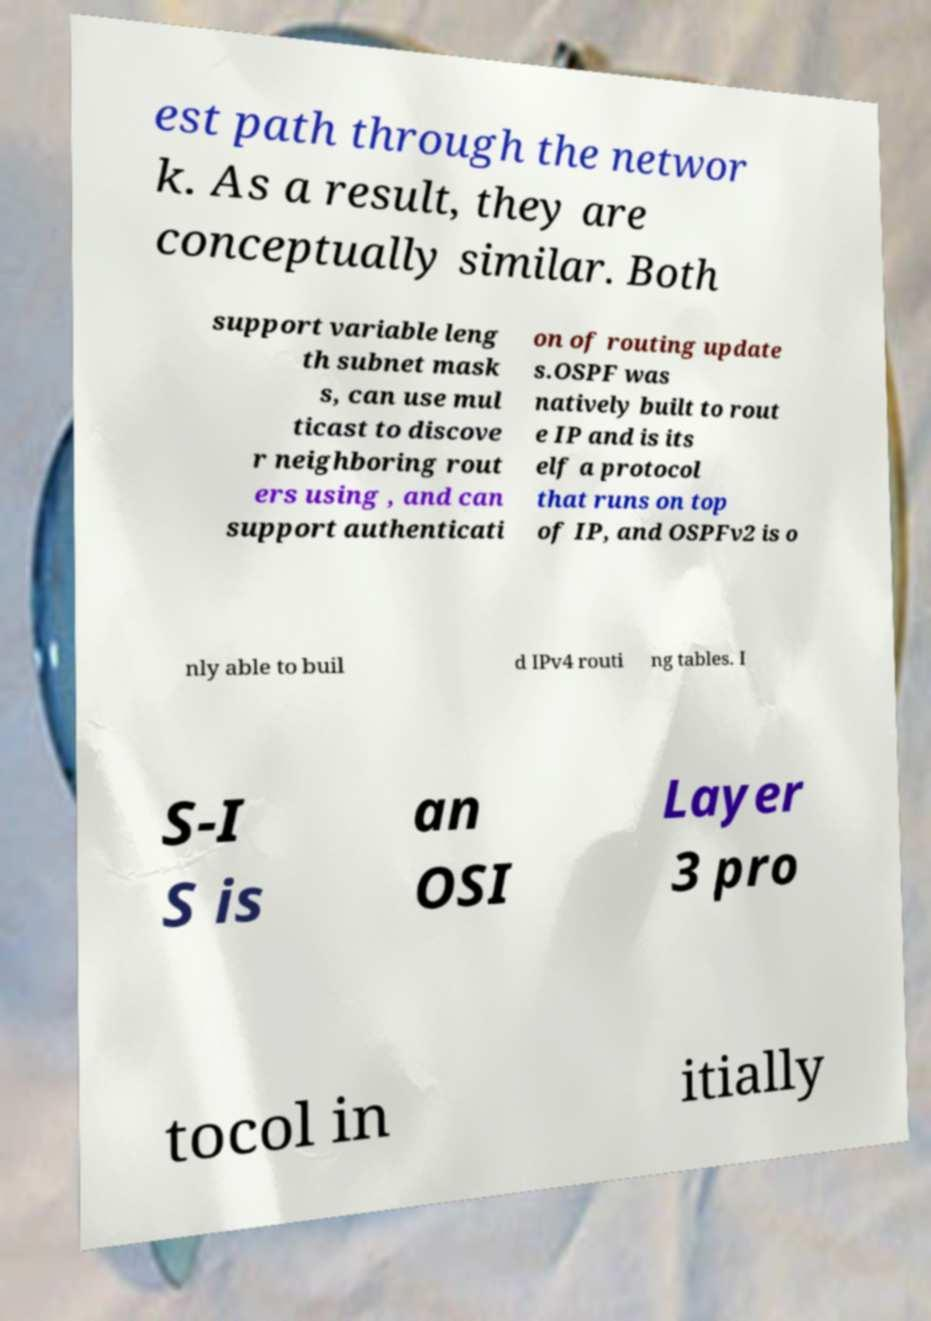What messages or text are displayed in this image? I need them in a readable, typed format. est path through the networ k. As a result, they are conceptually similar. Both support variable leng th subnet mask s, can use mul ticast to discove r neighboring rout ers using , and can support authenticati on of routing update s.OSPF was natively built to rout e IP and is its elf a protocol that runs on top of IP, and OSPFv2 is o nly able to buil d IPv4 routi ng tables. I S-I S is an OSI Layer 3 pro tocol in itially 